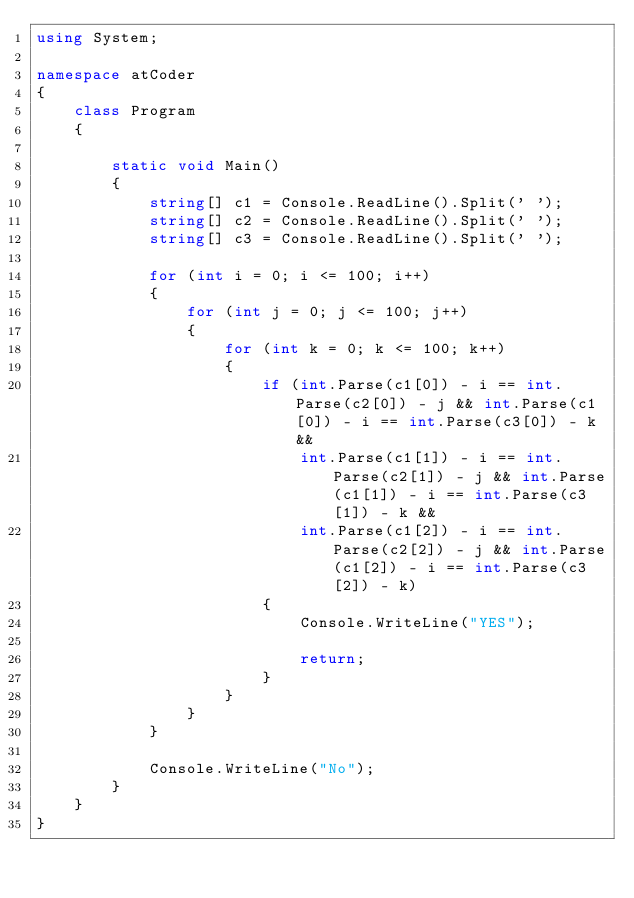Convert code to text. <code><loc_0><loc_0><loc_500><loc_500><_C#_>using System;

namespace atCoder
{
    class Program
    {

        static void Main()
        {
            string[] c1 = Console.ReadLine().Split(' ');
            string[] c2 = Console.ReadLine().Split(' ');
            string[] c3 = Console.ReadLine().Split(' ');

            for (int i = 0; i <= 100; i++)
            {
                for (int j = 0; j <= 100; j++)
                {
                    for (int k = 0; k <= 100; k++)
                    {
                        if (int.Parse(c1[0]) - i == int.Parse(c2[0]) - j && int.Parse(c1[0]) - i == int.Parse(c3[0]) - k &&
                            int.Parse(c1[1]) - i == int.Parse(c2[1]) - j && int.Parse(c1[1]) - i == int.Parse(c3[1]) - k &&
                            int.Parse(c1[2]) - i == int.Parse(c2[2]) - j && int.Parse(c1[2]) - i == int.Parse(c3[2]) - k)
                        {
                            Console.WriteLine("YES");

                            return;
                        }
                    }
                }
            }

            Console.WriteLine("No");
        }
    }
}</code> 